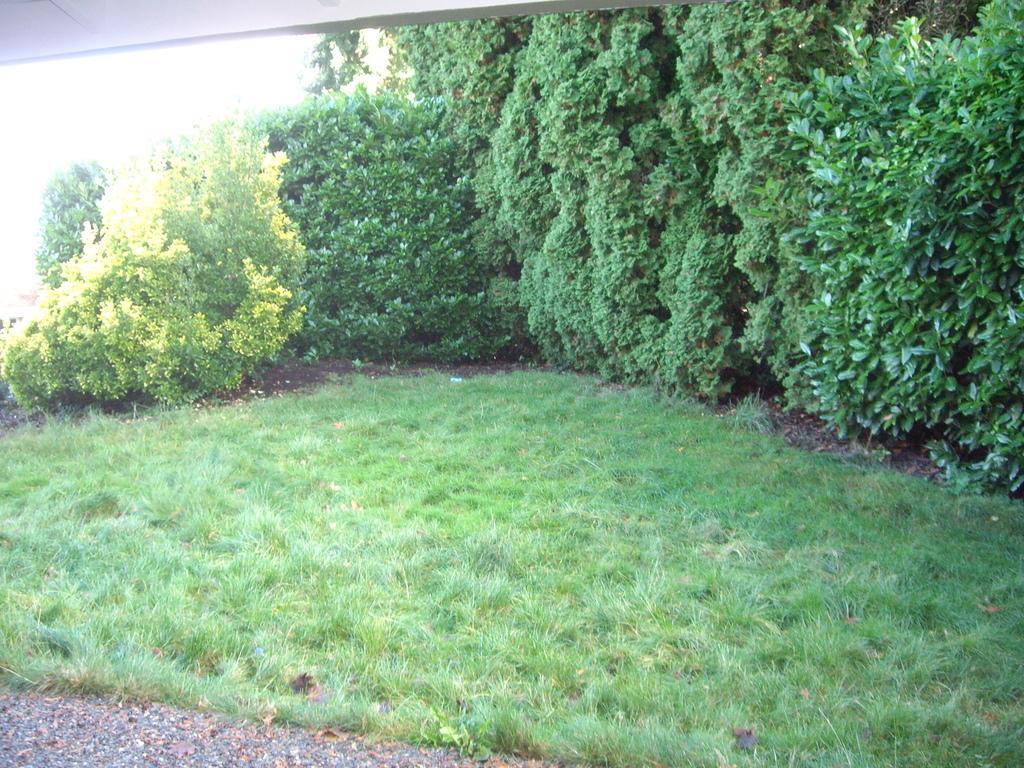How would you summarize this image in a sentence or two? In this picture there is greenery around the area of the image. 